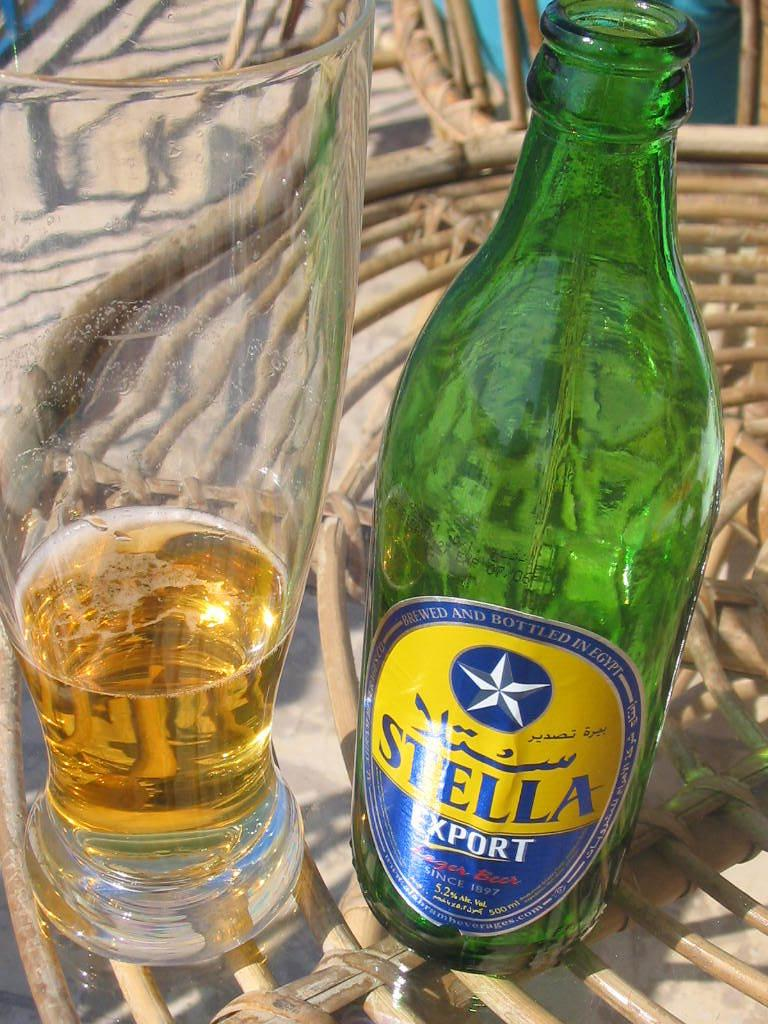Provide a one-sentence caption for the provided image. Stella Export fills the bottom of a glass and the empty bottle sits next to it. 